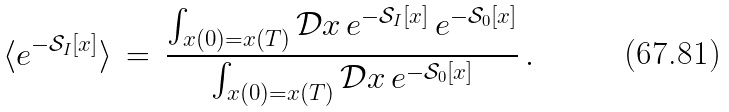Convert formula to latex. <formula><loc_0><loc_0><loc_500><loc_500>\langle e ^ { - { \mathcal { S } } _ { I } [ x ] } \rangle \, = \, \frac { \int _ { x ( 0 ) = x ( T ) } { \mathcal { D } } x \, e ^ { - { \mathcal { S } } _ { I } [ x ] } \, e ^ { - { \mathcal { S } } _ { 0 } [ x ] } } { \int _ { x ( 0 ) = x ( T ) } { \mathcal { D } } x \, e ^ { - { \mathcal { S } } _ { 0 } [ x ] } } \, .</formula> 